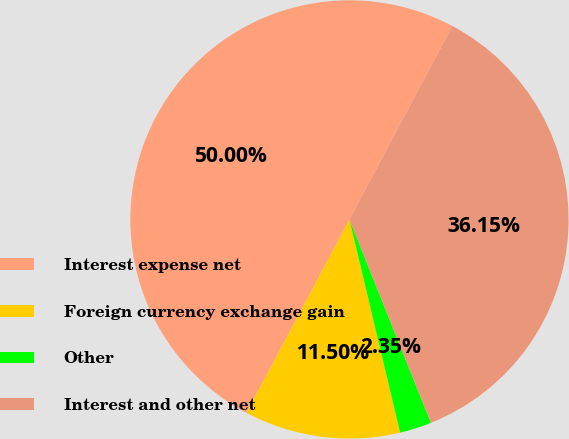Convert chart to OTSL. <chart><loc_0><loc_0><loc_500><loc_500><pie_chart><fcel>Interest expense net<fcel>Foreign currency exchange gain<fcel>Other<fcel>Interest and other net<nl><fcel>50.0%<fcel>11.5%<fcel>2.35%<fcel>36.15%<nl></chart> 